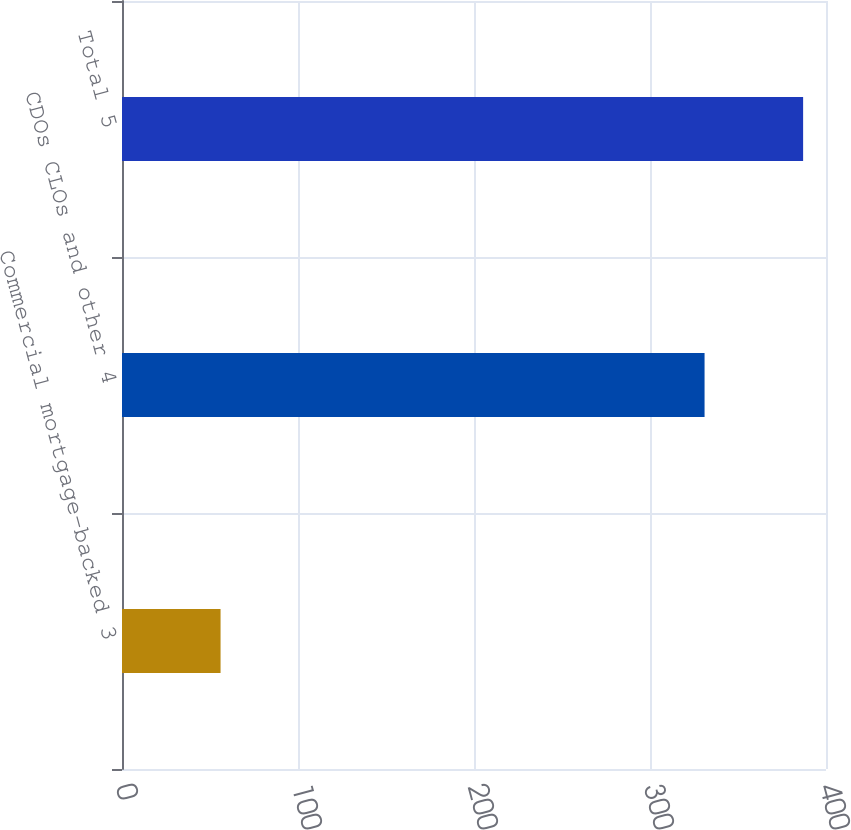Convert chart. <chart><loc_0><loc_0><loc_500><loc_500><bar_chart><fcel>Commercial mortgage-backed 3<fcel>CDOs CLOs and other 4<fcel>Total 5<nl><fcel>56<fcel>331<fcel>387<nl></chart> 